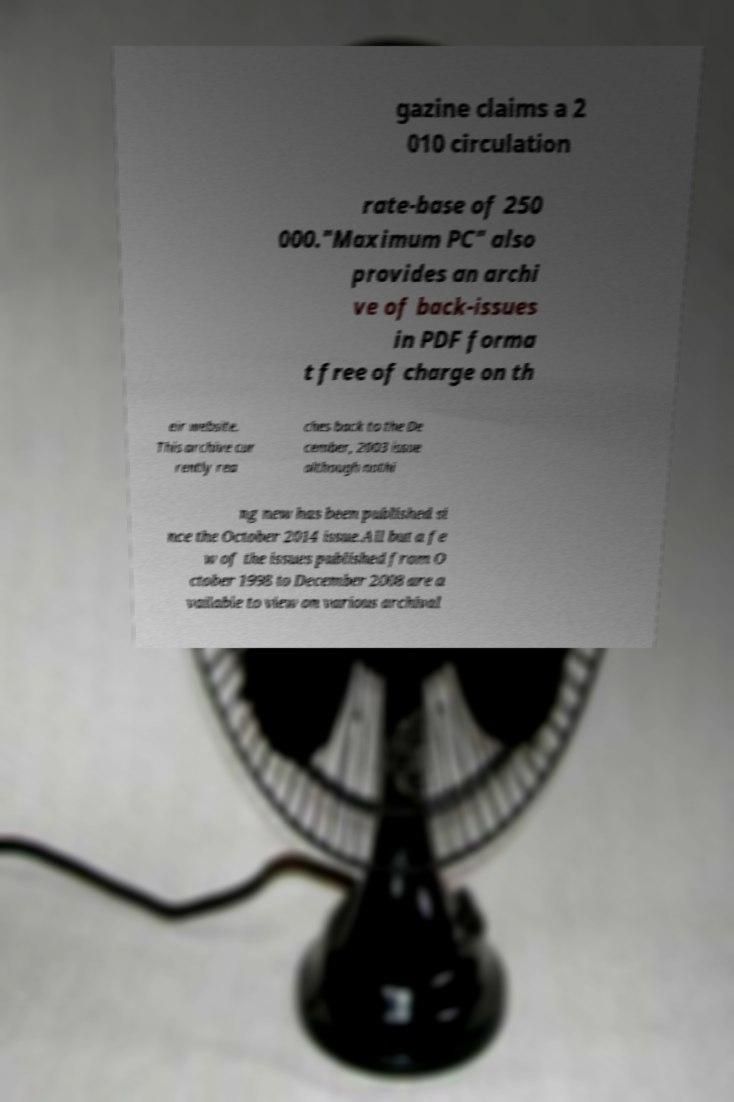Could you assist in decoding the text presented in this image and type it out clearly? gazine claims a 2 010 circulation rate-base of 250 000."Maximum PC" also provides an archi ve of back-issues in PDF forma t free of charge on th eir website. This archive cur rently rea ches back to the De cember, 2003 issue although nothi ng new has been published si nce the October 2014 issue.All but a fe w of the issues published from O ctober 1998 to December 2008 are a vailable to view on various archival 